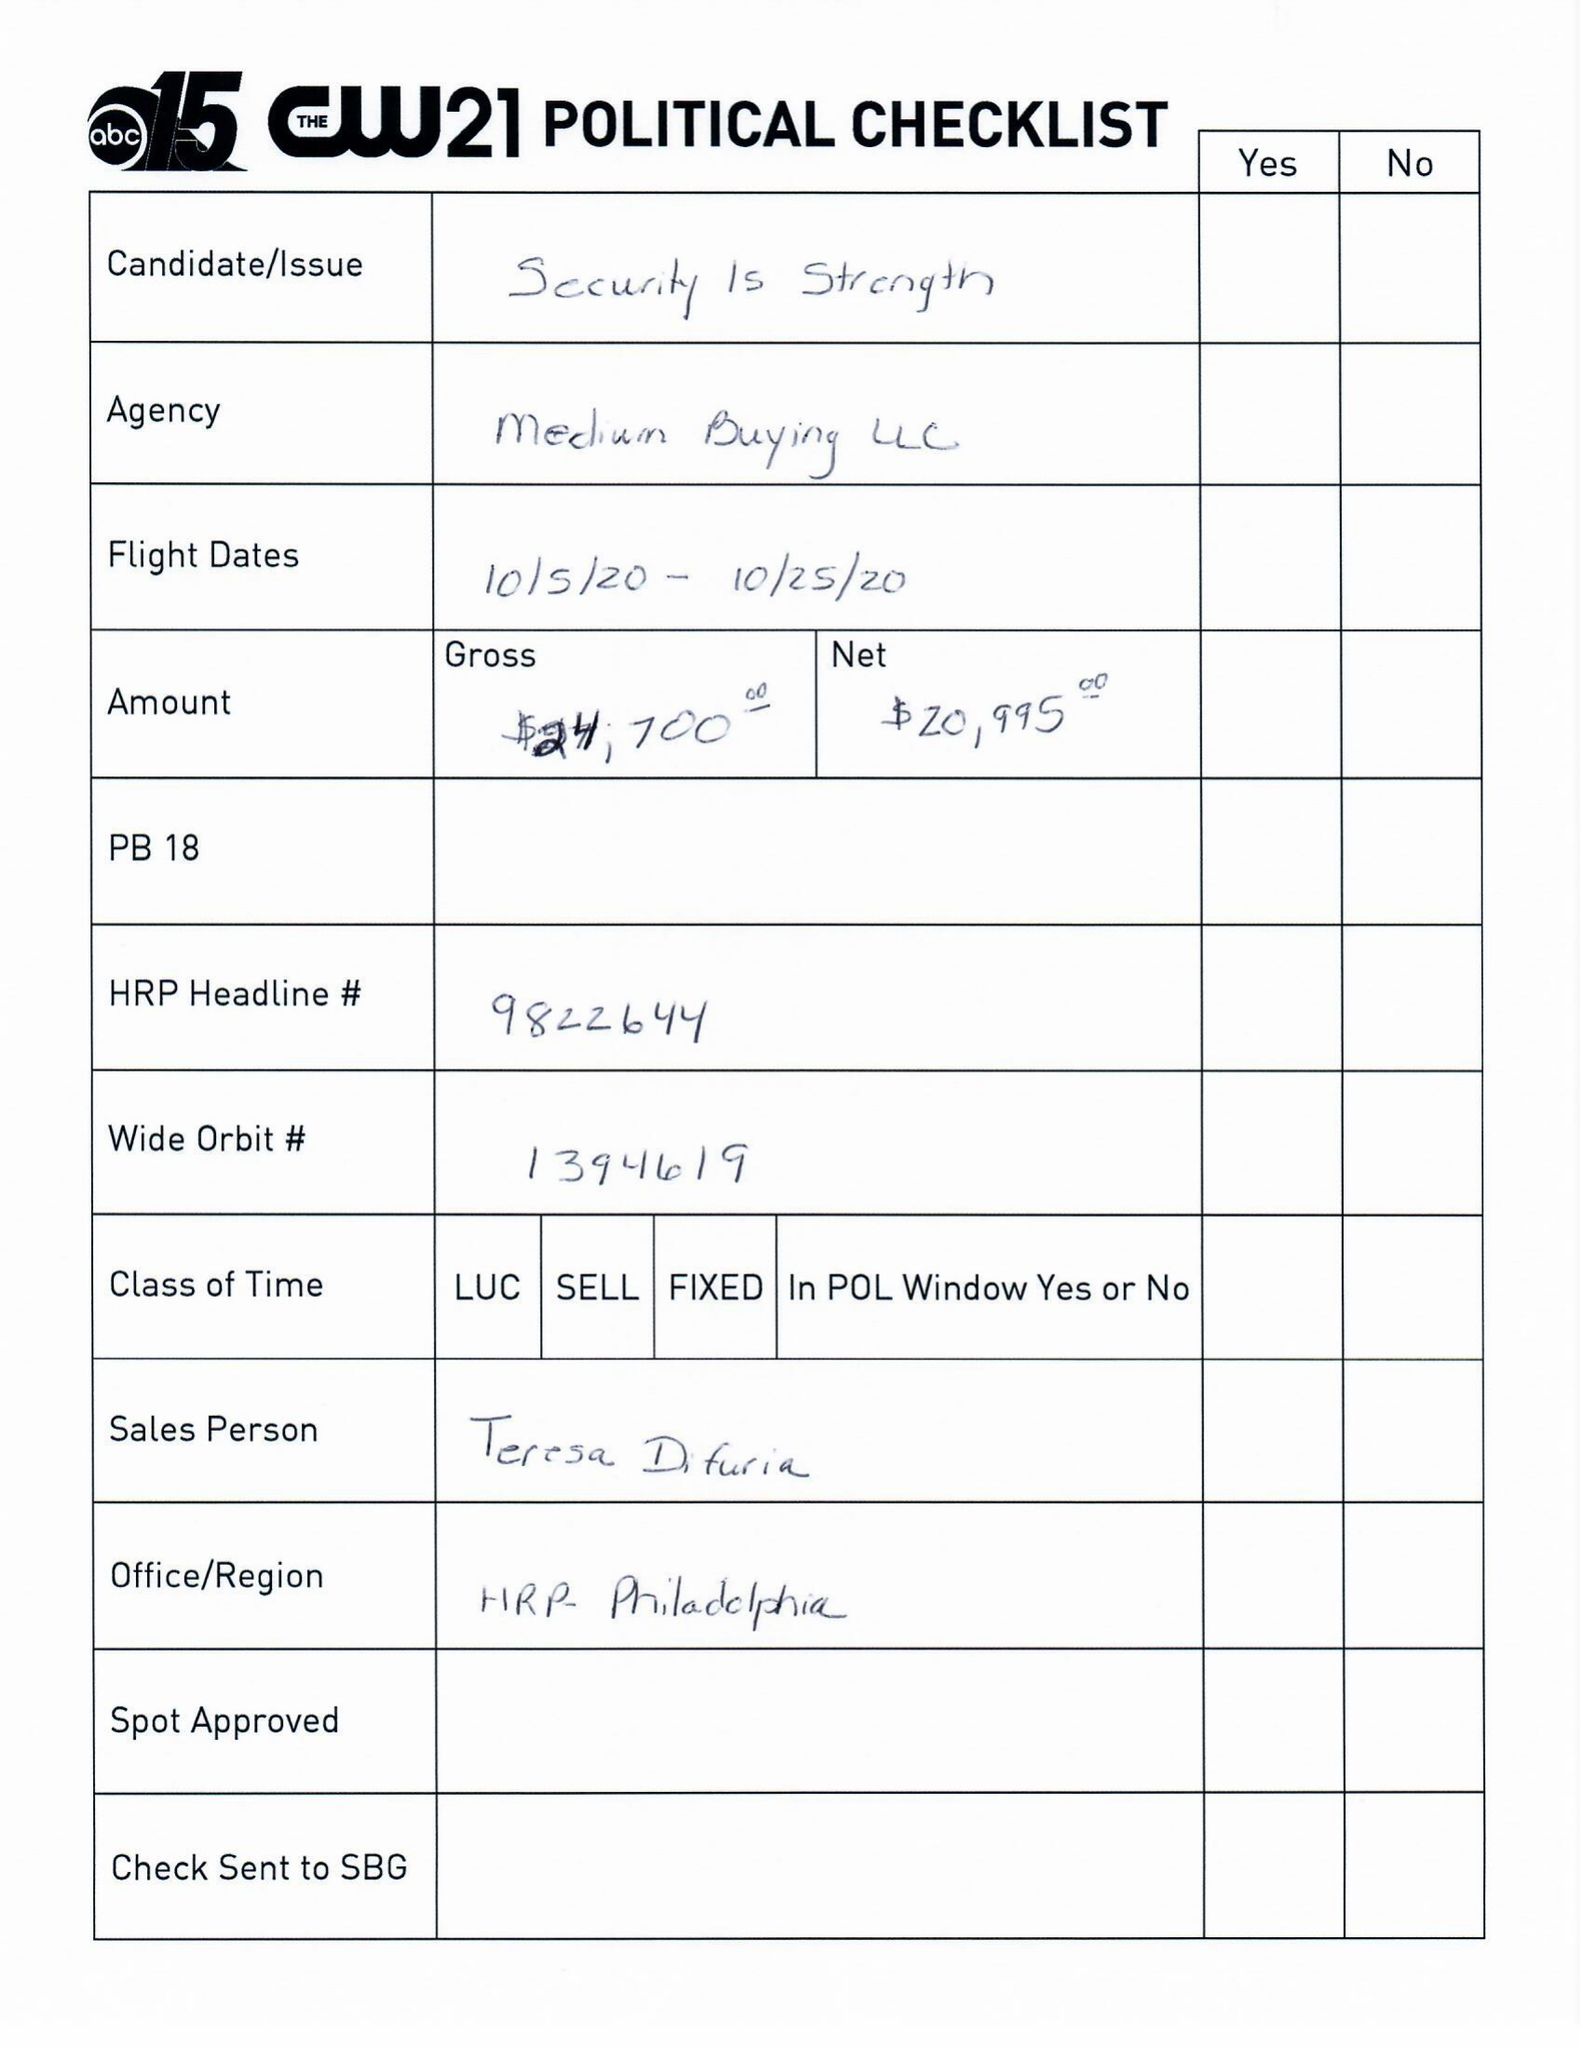What is the value for the advertiser?
Answer the question using a single word or phrase. SECURITY IS STRENGTH PAC 